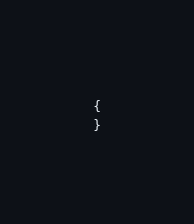Convert code to text. <code><loc_0><loc_0><loc_500><loc_500><_PHP_>{
}
</code> 